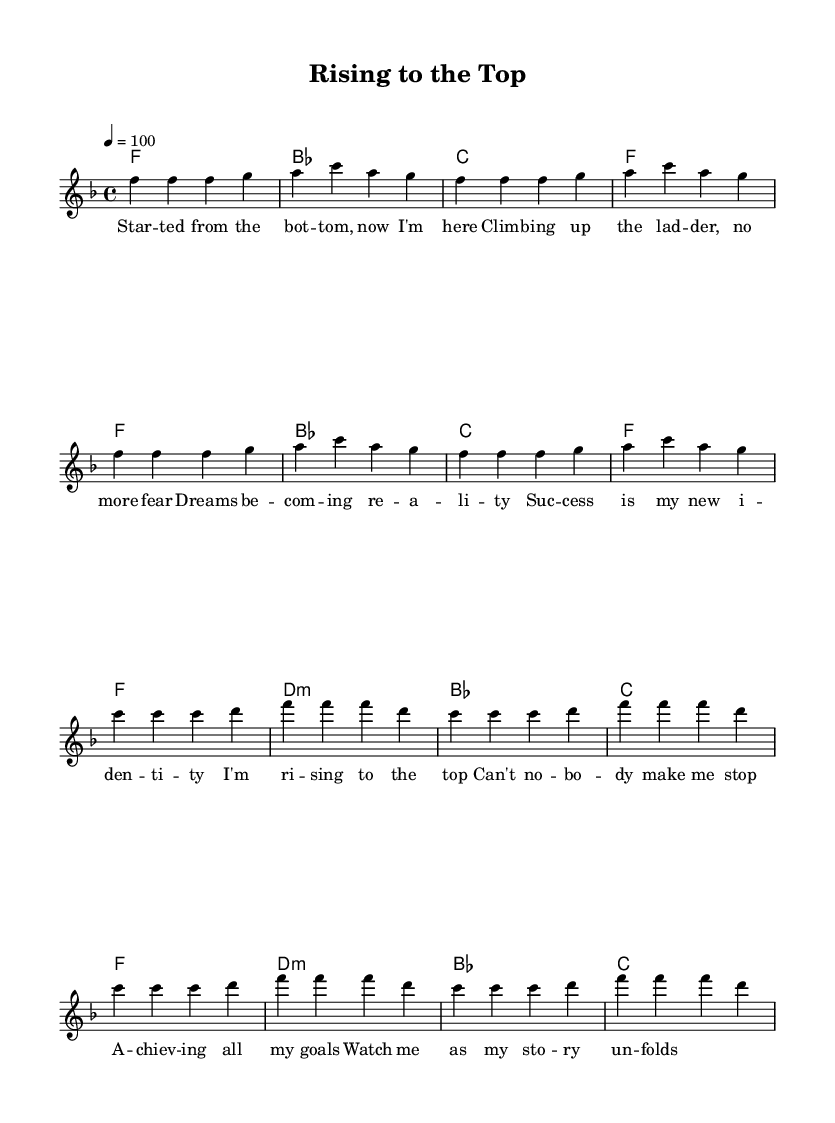What is the key signature of this music? The key signature is F major, which has one flat (B flat). This can be identified by looking at the key signature information at the beginning of the sheet music, where the flat is indicated.
Answer: F major What is the time signature of this music? The time signature is 4/4. This can be found at the beginning of the sheet music next to the key signature, indicating that there are four beats in a measure and the quarter note gets one beat.
Answer: 4/4 What is the tempo marking of this music? The tempo marking indicates a tempo of 100 beats per minute. This is specified in the score where "tempo 4 = 100" is mentioned, signifying the speed of the piece.
Answer: 100 How many measures are there in the chorus? The chorus consists of 8 measures. To find this, one can count the measures specified in the melodies and lyrics labeled as the chorus section.
Answer: 8 What type of musical form does this piece exhibit? This piece clearly shows a verse-chorus form, which is common in R&B tracks. The repetition of the verse and chorus sections indicates this structure, wherein the narrative builds up through the verses and culminates in the chorus.
Answer: Verse-chorus What is the name of the first chord in the verse? The first chord in the verse is F major. This can be determined by looking at the chord written above the first measure in the verse section of the sheet music.
Answer: F What thematic element is celebrated in the lyrics? The lyrics celebrate personal achievement and success. This can be identified by the phrases in the verse and chorus that refer to rising, climbing, and achieving goals, indicating the overall positive theme of the song.
Answer: Success 